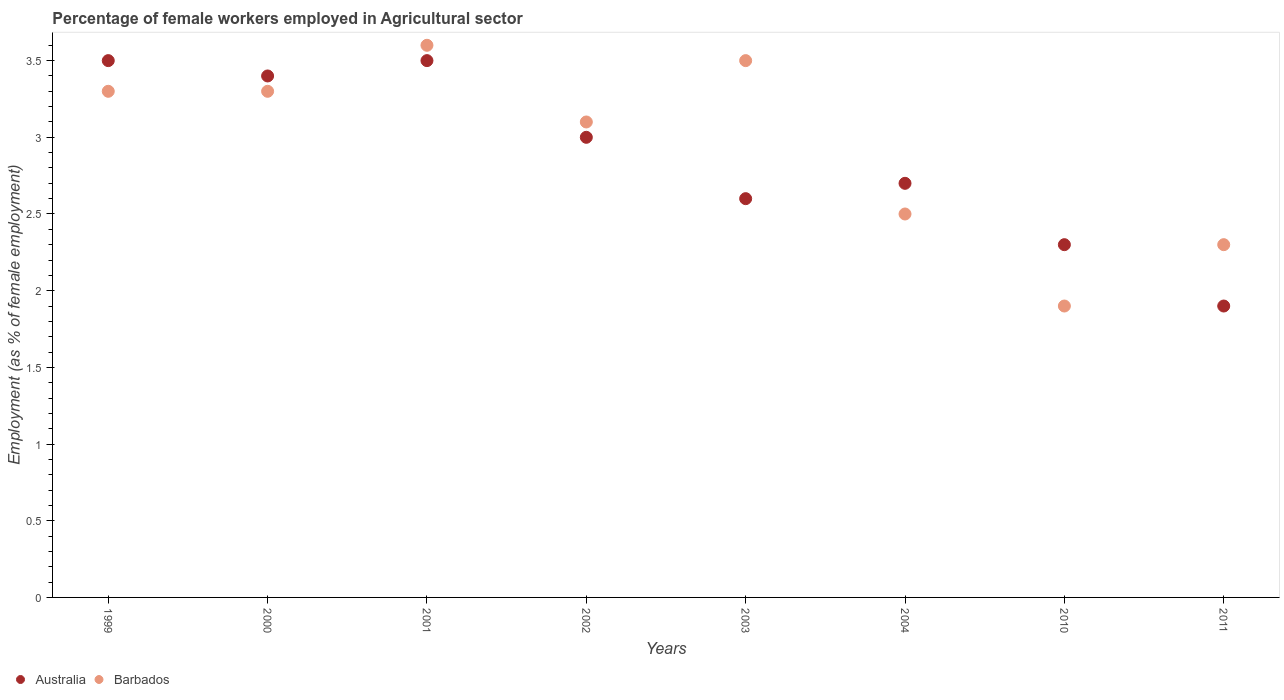Is the number of dotlines equal to the number of legend labels?
Ensure brevity in your answer.  Yes. What is the percentage of females employed in Agricultural sector in Barbados in 2001?
Your answer should be compact. 3.6. Across all years, what is the maximum percentage of females employed in Agricultural sector in Australia?
Ensure brevity in your answer.  3.5. Across all years, what is the minimum percentage of females employed in Agricultural sector in Barbados?
Provide a succinct answer. 1.9. In which year was the percentage of females employed in Agricultural sector in Australia maximum?
Offer a terse response. 1999. What is the total percentage of females employed in Agricultural sector in Barbados in the graph?
Keep it short and to the point. 23.5. What is the difference between the percentage of females employed in Agricultural sector in Barbados in 2004 and that in 2010?
Ensure brevity in your answer.  0.6. What is the difference between the percentage of females employed in Agricultural sector in Barbados in 2011 and the percentage of females employed in Agricultural sector in Australia in 2000?
Make the answer very short. -1.1. What is the average percentage of females employed in Agricultural sector in Australia per year?
Your answer should be very brief. 2.86. In the year 2002, what is the difference between the percentage of females employed in Agricultural sector in Australia and percentage of females employed in Agricultural sector in Barbados?
Keep it short and to the point. -0.1. In how many years, is the percentage of females employed in Agricultural sector in Barbados greater than 0.5 %?
Give a very brief answer. 8. What is the ratio of the percentage of females employed in Agricultural sector in Barbados in 2001 to that in 2003?
Keep it short and to the point. 1.03. Is the percentage of females employed in Agricultural sector in Australia in 2004 less than that in 2011?
Make the answer very short. No. What is the difference between the highest and the second highest percentage of females employed in Agricultural sector in Barbados?
Provide a short and direct response. 0.1. What is the difference between the highest and the lowest percentage of females employed in Agricultural sector in Australia?
Your answer should be compact. 1.6. In how many years, is the percentage of females employed in Agricultural sector in Barbados greater than the average percentage of females employed in Agricultural sector in Barbados taken over all years?
Offer a terse response. 5. Is the sum of the percentage of females employed in Agricultural sector in Barbados in 2004 and 2011 greater than the maximum percentage of females employed in Agricultural sector in Australia across all years?
Your response must be concise. Yes. Is the percentage of females employed in Agricultural sector in Australia strictly greater than the percentage of females employed in Agricultural sector in Barbados over the years?
Ensure brevity in your answer.  No. Is the percentage of females employed in Agricultural sector in Barbados strictly less than the percentage of females employed in Agricultural sector in Australia over the years?
Provide a short and direct response. No. How many years are there in the graph?
Provide a short and direct response. 8. What is the difference between two consecutive major ticks on the Y-axis?
Your answer should be compact. 0.5. Are the values on the major ticks of Y-axis written in scientific E-notation?
Ensure brevity in your answer.  No. Does the graph contain any zero values?
Your answer should be very brief. No. Where does the legend appear in the graph?
Make the answer very short. Bottom left. How many legend labels are there?
Provide a short and direct response. 2. What is the title of the graph?
Your answer should be very brief. Percentage of female workers employed in Agricultural sector. Does "Rwanda" appear as one of the legend labels in the graph?
Offer a terse response. No. What is the label or title of the Y-axis?
Offer a very short reply. Employment (as % of female employment). What is the Employment (as % of female employment) of Barbados in 1999?
Offer a very short reply. 3.3. What is the Employment (as % of female employment) of Australia in 2000?
Give a very brief answer. 3.4. What is the Employment (as % of female employment) in Barbados in 2000?
Your answer should be very brief. 3.3. What is the Employment (as % of female employment) of Australia in 2001?
Offer a terse response. 3.5. What is the Employment (as % of female employment) of Barbados in 2001?
Make the answer very short. 3.6. What is the Employment (as % of female employment) of Australia in 2002?
Make the answer very short. 3. What is the Employment (as % of female employment) of Barbados in 2002?
Make the answer very short. 3.1. What is the Employment (as % of female employment) of Australia in 2003?
Offer a terse response. 2.6. What is the Employment (as % of female employment) of Barbados in 2003?
Offer a very short reply. 3.5. What is the Employment (as % of female employment) of Australia in 2004?
Offer a very short reply. 2.7. What is the Employment (as % of female employment) in Australia in 2010?
Offer a terse response. 2.3. What is the Employment (as % of female employment) of Barbados in 2010?
Provide a short and direct response. 1.9. What is the Employment (as % of female employment) in Australia in 2011?
Provide a short and direct response. 1.9. What is the Employment (as % of female employment) in Barbados in 2011?
Offer a very short reply. 2.3. Across all years, what is the maximum Employment (as % of female employment) in Australia?
Keep it short and to the point. 3.5. Across all years, what is the maximum Employment (as % of female employment) in Barbados?
Keep it short and to the point. 3.6. Across all years, what is the minimum Employment (as % of female employment) of Australia?
Your response must be concise. 1.9. Across all years, what is the minimum Employment (as % of female employment) in Barbados?
Give a very brief answer. 1.9. What is the total Employment (as % of female employment) in Australia in the graph?
Offer a very short reply. 22.9. What is the total Employment (as % of female employment) in Barbados in the graph?
Ensure brevity in your answer.  23.5. What is the difference between the Employment (as % of female employment) of Barbados in 1999 and that in 2000?
Your answer should be compact. 0. What is the difference between the Employment (as % of female employment) in Australia in 1999 and that in 2002?
Give a very brief answer. 0.5. What is the difference between the Employment (as % of female employment) of Barbados in 1999 and that in 2002?
Your response must be concise. 0.2. What is the difference between the Employment (as % of female employment) of Barbados in 1999 and that in 2004?
Your answer should be compact. 0.8. What is the difference between the Employment (as % of female employment) of Barbados in 1999 and that in 2010?
Give a very brief answer. 1.4. What is the difference between the Employment (as % of female employment) of Australia in 1999 and that in 2011?
Keep it short and to the point. 1.6. What is the difference between the Employment (as % of female employment) in Barbados in 2000 and that in 2001?
Keep it short and to the point. -0.3. What is the difference between the Employment (as % of female employment) in Australia in 2000 and that in 2002?
Ensure brevity in your answer.  0.4. What is the difference between the Employment (as % of female employment) of Barbados in 2000 and that in 2002?
Give a very brief answer. 0.2. What is the difference between the Employment (as % of female employment) in Australia in 2000 and that in 2004?
Provide a succinct answer. 0.7. What is the difference between the Employment (as % of female employment) in Australia in 2000 and that in 2010?
Provide a short and direct response. 1.1. What is the difference between the Employment (as % of female employment) of Barbados in 2000 and that in 2010?
Your answer should be very brief. 1.4. What is the difference between the Employment (as % of female employment) in Australia in 2000 and that in 2011?
Your answer should be very brief. 1.5. What is the difference between the Employment (as % of female employment) of Barbados in 2001 and that in 2002?
Offer a terse response. 0.5. What is the difference between the Employment (as % of female employment) of Australia in 2001 and that in 2004?
Keep it short and to the point. 0.8. What is the difference between the Employment (as % of female employment) of Barbados in 2001 and that in 2004?
Your answer should be very brief. 1.1. What is the difference between the Employment (as % of female employment) in Australia in 2002 and that in 2004?
Ensure brevity in your answer.  0.3. What is the difference between the Employment (as % of female employment) in Australia in 2002 and that in 2010?
Your response must be concise. 0.7. What is the difference between the Employment (as % of female employment) of Australia in 2003 and that in 2004?
Keep it short and to the point. -0.1. What is the difference between the Employment (as % of female employment) of Barbados in 2003 and that in 2004?
Make the answer very short. 1. What is the difference between the Employment (as % of female employment) in Australia in 2003 and that in 2010?
Provide a short and direct response. 0.3. What is the difference between the Employment (as % of female employment) in Barbados in 2003 and that in 2010?
Your answer should be very brief. 1.6. What is the difference between the Employment (as % of female employment) in Barbados in 2003 and that in 2011?
Ensure brevity in your answer.  1.2. What is the difference between the Employment (as % of female employment) in Barbados in 2004 and that in 2010?
Provide a short and direct response. 0.6. What is the difference between the Employment (as % of female employment) of Australia in 2004 and that in 2011?
Give a very brief answer. 0.8. What is the difference between the Employment (as % of female employment) in Australia in 2010 and that in 2011?
Your answer should be compact. 0.4. What is the difference between the Employment (as % of female employment) in Australia in 1999 and the Employment (as % of female employment) in Barbados in 2002?
Give a very brief answer. 0.4. What is the difference between the Employment (as % of female employment) of Australia in 1999 and the Employment (as % of female employment) of Barbados in 2003?
Offer a terse response. 0. What is the difference between the Employment (as % of female employment) in Australia in 1999 and the Employment (as % of female employment) in Barbados in 2004?
Provide a succinct answer. 1. What is the difference between the Employment (as % of female employment) of Australia in 2000 and the Employment (as % of female employment) of Barbados in 2001?
Your answer should be compact. -0.2. What is the difference between the Employment (as % of female employment) in Australia in 2000 and the Employment (as % of female employment) in Barbados in 2002?
Your answer should be very brief. 0.3. What is the difference between the Employment (as % of female employment) of Australia in 2000 and the Employment (as % of female employment) of Barbados in 2003?
Your response must be concise. -0.1. What is the difference between the Employment (as % of female employment) in Australia in 2000 and the Employment (as % of female employment) in Barbados in 2004?
Provide a short and direct response. 0.9. What is the difference between the Employment (as % of female employment) in Australia in 2000 and the Employment (as % of female employment) in Barbados in 2011?
Ensure brevity in your answer.  1.1. What is the difference between the Employment (as % of female employment) in Australia in 2001 and the Employment (as % of female employment) in Barbados in 2002?
Your answer should be compact. 0.4. What is the difference between the Employment (as % of female employment) of Australia in 2001 and the Employment (as % of female employment) of Barbados in 2004?
Provide a succinct answer. 1. What is the difference between the Employment (as % of female employment) in Australia in 2002 and the Employment (as % of female employment) in Barbados in 2011?
Provide a short and direct response. 0.7. What is the difference between the Employment (as % of female employment) of Australia in 2003 and the Employment (as % of female employment) of Barbados in 2010?
Keep it short and to the point. 0.7. What is the difference between the Employment (as % of female employment) in Australia in 2004 and the Employment (as % of female employment) in Barbados in 2010?
Provide a succinct answer. 0.8. What is the average Employment (as % of female employment) of Australia per year?
Your answer should be very brief. 2.86. What is the average Employment (as % of female employment) of Barbados per year?
Offer a terse response. 2.94. In the year 2003, what is the difference between the Employment (as % of female employment) of Australia and Employment (as % of female employment) of Barbados?
Offer a terse response. -0.9. What is the ratio of the Employment (as % of female employment) of Australia in 1999 to that in 2000?
Offer a very short reply. 1.03. What is the ratio of the Employment (as % of female employment) in Barbados in 1999 to that in 2000?
Your answer should be compact. 1. What is the ratio of the Employment (as % of female employment) of Australia in 1999 to that in 2001?
Your answer should be very brief. 1. What is the ratio of the Employment (as % of female employment) in Barbados in 1999 to that in 2001?
Your answer should be compact. 0.92. What is the ratio of the Employment (as % of female employment) of Barbados in 1999 to that in 2002?
Offer a very short reply. 1.06. What is the ratio of the Employment (as % of female employment) in Australia in 1999 to that in 2003?
Provide a short and direct response. 1.35. What is the ratio of the Employment (as % of female employment) of Barbados in 1999 to that in 2003?
Your answer should be compact. 0.94. What is the ratio of the Employment (as % of female employment) in Australia in 1999 to that in 2004?
Ensure brevity in your answer.  1.3. What is the ratio of the Employment (as % of female employment) of Barbados in 1999 to that in 2004?
Your answer should be compact. 1.32. What is the ratio of the Employment (as % of female employment) in Australia in 1999 to that in 2010?
Offer a very short reply. 1.52. What is the ratio of the Employment (as % of female employment) of Barbados in 1999 to that in 2010?
Your answer should be very brief. 1.74. What is the ratio of the Employment (as % of female employment) in Australia in 1999 to that in 2011?
Your answer should be compact. 1.84. What is the ratio of the Employment (as % of female employment) of Barbados in 1999 to that in 2011?
Your response must be concise. 1.43. What is the ratio of the Employment (as % of female employment) in Australia in 2000 to that in 2001?
Provide a short and direct response. 0.97. What is the ratio of the Employment (as % of female employment) of Australia in 2000 to that in 2002?
Keep it short and to the point. 1.13. What is the ratio of the Employment (as % of female employment) in Barbados in 2000 to that in 2002?
Give a very brief answer. 1.06. What is the ratio of the Employment (as % of female employment) in Australia in 2000 to that in 2003?
Give a very brief answer. 1.31. What is the ratio of the Employment (as % of female employment) of Barbados in 2000 to that in 2003?
Keep it short and to the point. 0.94. What is the ratio of the Employment (as % of female employment) in Australia in 2000 to that in 2004?
Provide a succinct answer. 1.26. What is the ratio of the Employment (as % of female employment) of Barbados in 2000 to that in 2004?
Your answer should be very brief. 1.32. What is the ratio of the Employment (as % of female employment) in Australia in 2000 to that in 2010?
Provide a short and direct response. 1.48. What is the ratio of the Employment (as % of female employment) in Barbados in 2000 to that in 2010?
Provide a short and direct response. 1.74. What is the ratio of the Employment (as % of female employment) in Australia in 2000 to that in 2011?
Offer a terse response. 1.79. What is the ratio of the Employment (as % of female employment) in Barbados in 2000 to that in 2011?
Ensure brevity in your answer.  1.43. What is the ratio of the Employment (as % of female employment) of Australia in 2001 to that in 2002?
Keep it short and to the point. 1.17. What is the ratio of the Employment (as % of female employment) in Barbados in 2001 to that in 2002?
Keep it short and to the point. 1.16. What is the ratio of the Employment (as % of female employment) of Australia in 2001 to that in 2003?
Keep it short and to the point. 1.35. What is the ratio of the Employment (as % of female employment) of Barbados in 2001 to that in 2003?
Your answer should be compact. 1.03. What is the ratio of the Employment (as % of female employment) in Australia in 2001 to that in 2004?
Keep it short and to the point. 1.3. What is the ratio of the Employment (as % of female employment) of Barbados in 2001 to that in 2004?
Your response must be concise. 1.44. What is the ratio of the Employment (as % of female employment) in Australia in 2001 to that in 2010?
Provide a short and direct response. 1.52. What is the ratio of the Employment (as % of female employment) of Barbados in 2001 to that in 2010?
Keep it short and to the point. 1.89. What is the ratio of the Employment (as % of female employment) of Australia in 2001 to that in 2011?
Provide a short and direct response. 1.84. What is the ratio of the Employment (as % of female employment) of Barbados in 2001 to that in 2011?
Make the answer very short. 1.57. What is the ratio of the Employment (as % of female employment) in Australia in 2002 to that in 2003?
Give a very brief answer. 1.15. What is the ratio of the Employment (as % of female employment) in Barbados in 2002 to that in 2003?
Provide a succinct answer. 0.89. What is the ratio of the Employment (as % of female employment) of Australia in 2002 to that in 2004?
Your answer should be very brief. 1.11. What is the ratio of the Employment (as % of female employment) in Barbados in 2002 to that in 2004?
Offer a terse response. 1.24. What is the ratio of the Employment (as % of female employment) in Australia in 2002 to that in 2010?
Provide a succinct answer. 1.3. What is the ratio of the Employment (as % of female employment) of Barbados in 2002 to that in 2010?
Offer a terse response. 1.63. What is the ratio of the Employment (as % of female employment) in Australia in 2002 to that in 2011?
Provide a short and direct response. 1.58. What is the ratio of the Employment (as % of female employment) in Barbados in 2002 to that in 2011?
Offer a very short reply. 1.35. What is the ratio of the Employment (as % of female employment) in Australia in 2003 to that in 2010?
Ensure brevity in your answer.  1.13. What is the ratio of the Employment (as % of female employment) in Barbados in 2003 to that in 2010?
Offer a very short reply. 1.84. What is the ratio of the Employment (as % of female employment) in Australia in 2003 to that in 2011?
Your answer should be compact. 1.37. What is the ratio of the Employment (as % of female employment) in Barbados in 2003 to that in 2011?
Provide a succinct answer. 1.52. What is the ratio of the Employment (as % of female employment) of Australia in 2004 to that in 2010?
Your answer should be compact. 1.17. What is the ratio of the Employment (as % of female employment) in Barbados in 2004 to that in 2010?
Provide a short and direct response. 1.32. What is the ratio of the Employment (as % of female employment) in Australia in 2004 to that in 2011?
Offer a terse response. 1.42. What is the ratio of the Employment (as % of female employment) of Barbados in 2004 to that in 2011?
Keep it short and to the point. 1.09. What is the ratio of the Employment (as % of female employment) of Australia in 2010 to that in 2011?
Keep it short and to the point. 1.21. What is the ratio of the Employment (as % of female employment) in Barbados in 2010 to that in 2011?
Offer a terse response. 0.83. 